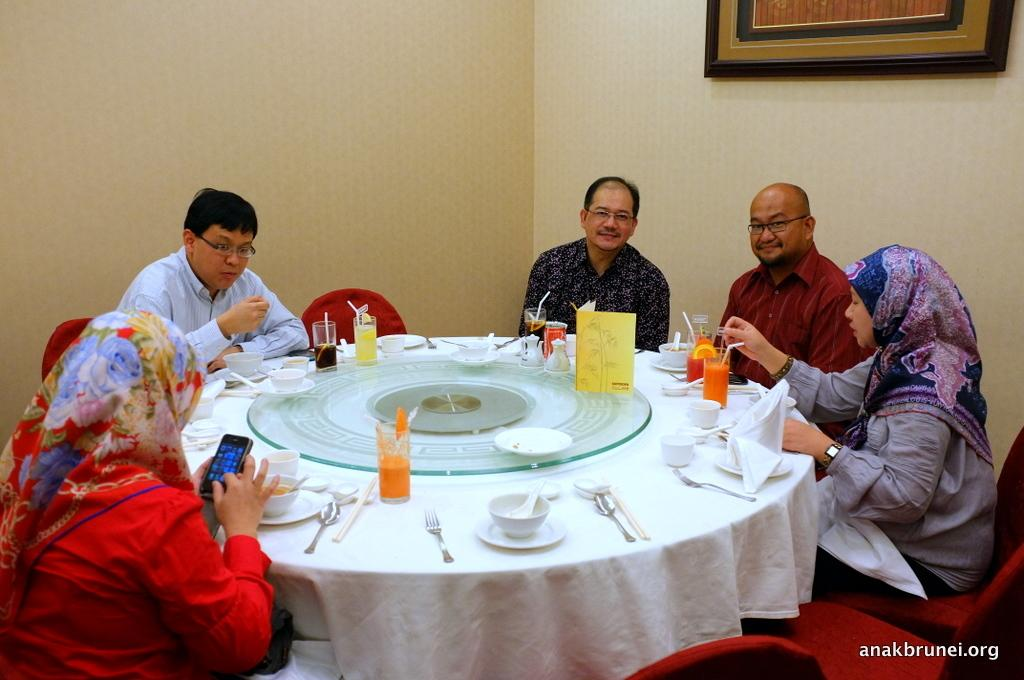How many people are in the image? There is a group of people in the image. What are the people doing in the image? The people are seated on chairs. Can you describe the woman's activity in the image? There is a woman using her mobile in the image. What items can be seen on the table in the image? There are plates, bowls, and glasses on the table. What type of vegetable is being used as a brake in the image? There is no vegetable being used as a brake in the image, as the image does not depict any vehicles or braking mechanisms. 